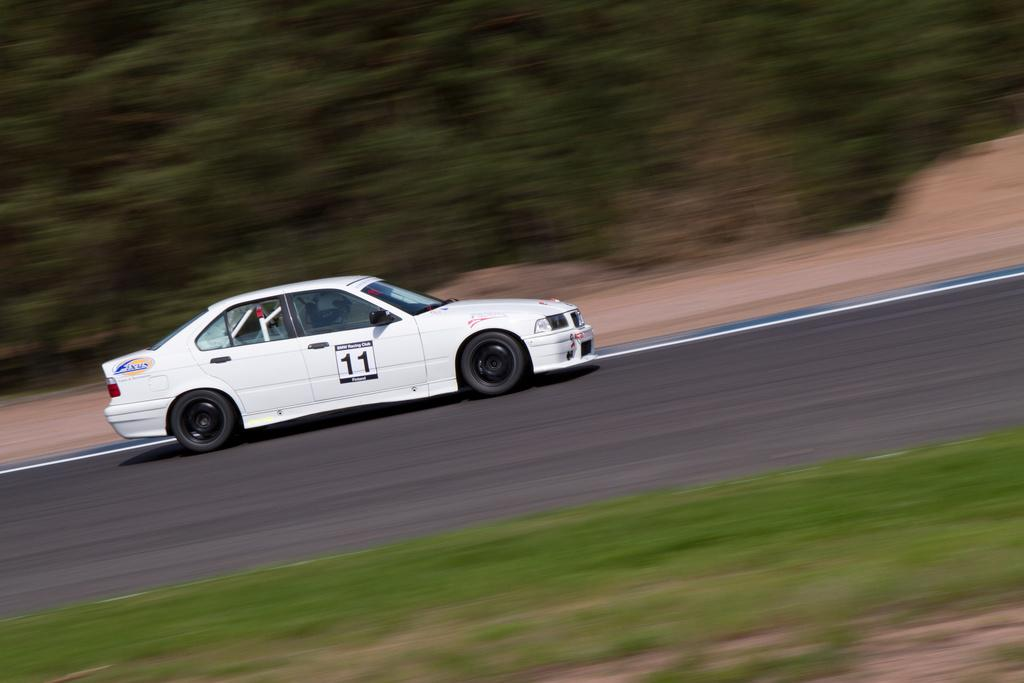What is the main subject of the image? The main subject of the image is a car. Where is the car located in the image? The car is on the road in the image. What can be seen in the background of the image? There are trees in the background of the image. What type of bean is growing on the car in the image? There are no beans present in the image, and the car is not associated with any bean growth. 